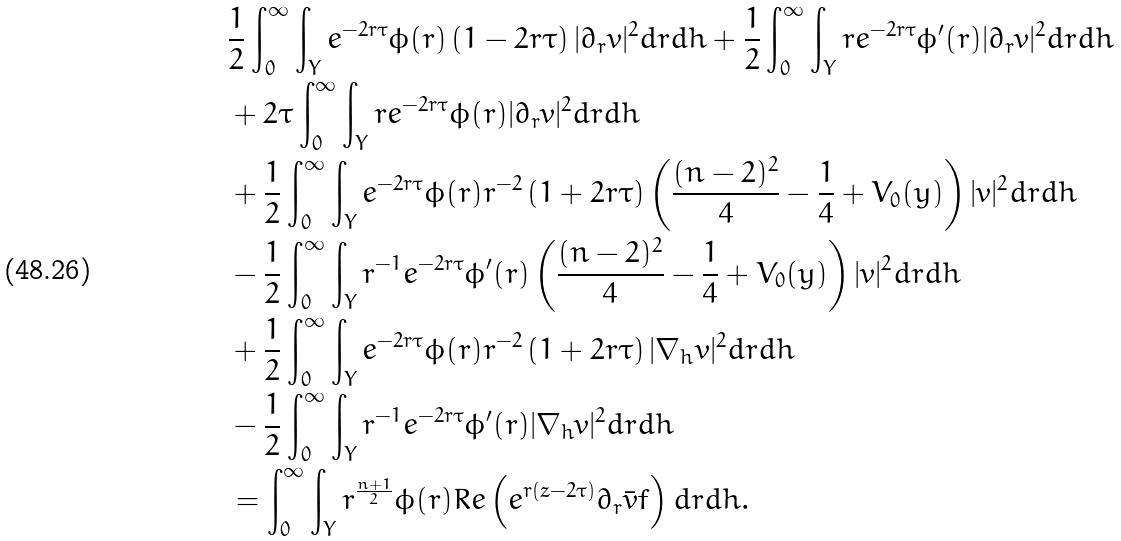<formula> <loc_0><loc_0><loc_500><loc_500>& \frac { 1 } { 2 } \int _ { 0 } ^ { \infty } \int _ { Y } e ^ { - 2 r \tau } \phi ( r ) \left ( 1 - 2 r \tau \right ) | \partial _ { r } v | ^ { 2 } d r d h + \frac { 1 } { 2 } \int _ { 0 } ^ { \infty } \int _ { Y } r e ^ { - 2 r \tau } \phi ^ { \prime } ( r ) | \partial _ { r } v | ^ { 2 } d r d h \\ & + 2 \tau \int _ { 0 } ^ { \infty } \int _ { Y } r e ^ { - 2 r \tau } \phi ( r ) | \partial _ { r } v | ^ { 2 } d r d h \\ & + \frac { 1 } { 2 } \int _ { 0 } ^ { \infty } \int _ { Y } e ^ { - 2 r \tau } \phi ( r ) r ^ { - 2 } \left ( 1 + 2 r \tau \right ) \left ( \frac { ( n - 2 ) ^ { 2 } } { 4 } - \frac { 1 } { 4 } + V _ { 0 } ( y ) \right ) | v | ^ { 2 } d r d h \\ & - \frac { 1 } { 2 } \int _ { 0 } ^ { \infty } \int _ { Y } r ^ { - 1 } e ^ { - 2 r \tau } \phi ^ { \prime } ( r ) \left ( \frac { ( n - 2 ) ^ { 2 } } { 4 } - \frac { 1 } { 4 } + V _ { 0 } ( y ) \right ) | v | ^ { 2 } d r d h \\ \quad & + \frac { 1 } { 2 } \int _ { 0 } ^ { \infty } \int _ { Y } e ^ { - 2 r \tau } \phi ( r ) r ^ { - 2 } \left ( 1 + 2 r \tau \right ) | \nabla _ { h } v | ^ { 2 } d r d h \\ & - \frac { 1 } { 2 } \int _ { 0 } ^ { \infty } \int _ { Y } r ^ { - 1 } e ^ { - 2 r \tau } \phi ^ { \prime } ( r ) | \nabla _ { h } v | ^ { 2 } d r d h \\ & = \int _ { 0 } ^ { \infty } \int _ { Y } r ^ { \frac { n + 1 } 2 } \phi ( r ) R e \left ( e ^ { r ( z - 2 \tau ) } \partial _ { r } \bar { v } f \right ) d r d h .</formula> 